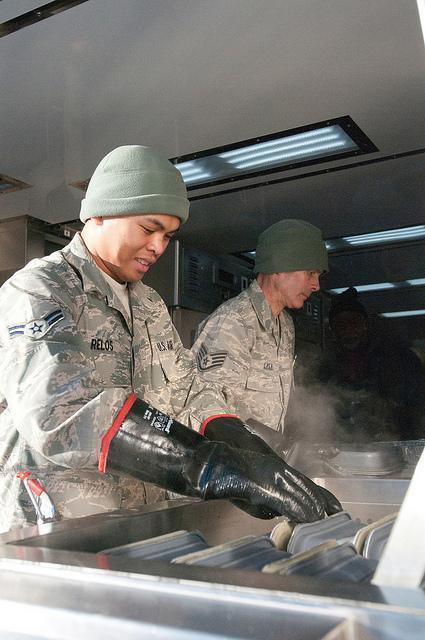How many people are there?
Give a very brief answer. 2. 